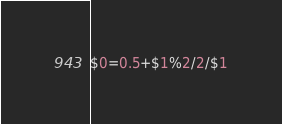Convert code to text. <code><loc_0><loc_0><loc_500><loc_500><_Awk_>$0=0.5+$1%2/2/$1</code> 